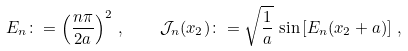Convert formula to latex. <formula><loc_0><loc_0><loc_500><loc_500>E _ { n } \colon = \left ( \frac { n \pi } { 2 a } \right ) ^ { 2 } \, , \quad \mathcal { J } _ { n } ( x _ { 2 } ) \colon = \sqrt { \frac { 1 } { a } } \, \sin \left [ E _ { n } ( x _ { 2 } + a ) \right ] \, ,</formula> 